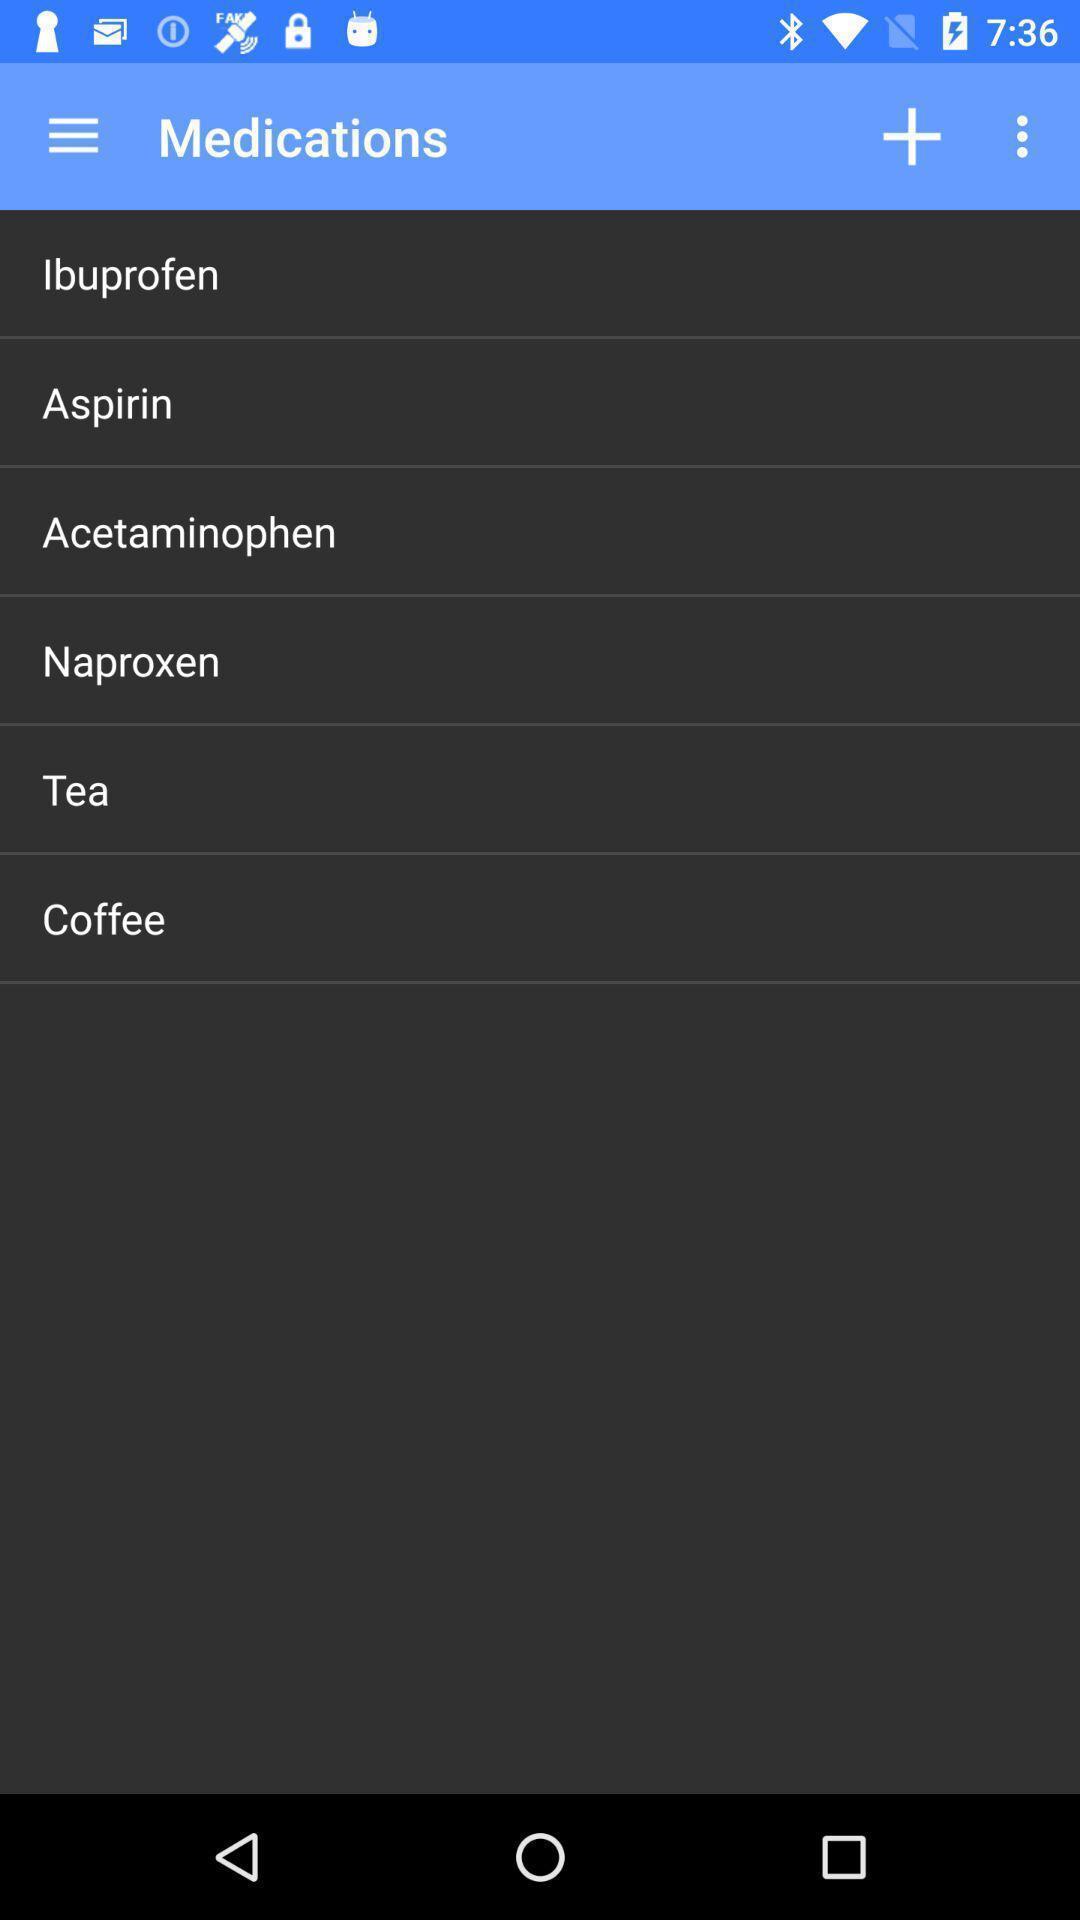Tell me about the visual elements in this screen capture. Page showing list of medications on an app. 